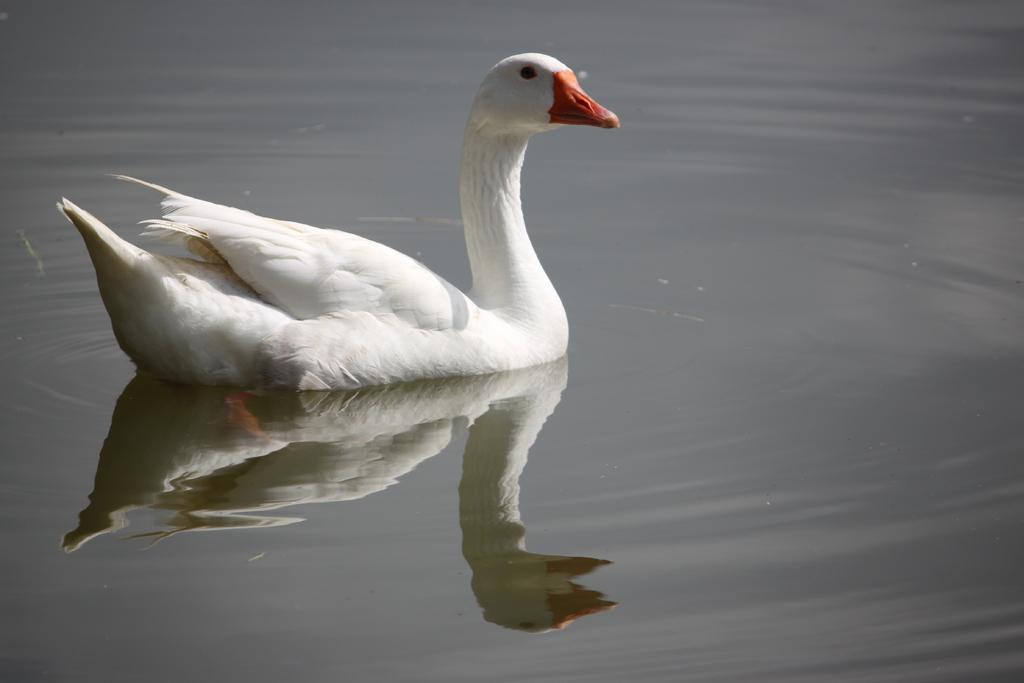What animal is present in the image? There is a duck in the image. Where is the duck located? The duck is in the water. Can you describe any additional features of the image? The image shows the reflection of the duck. How many grapes are on the duck's back in the image? There are no grapes present in the image, and the duck's back is not visible. 